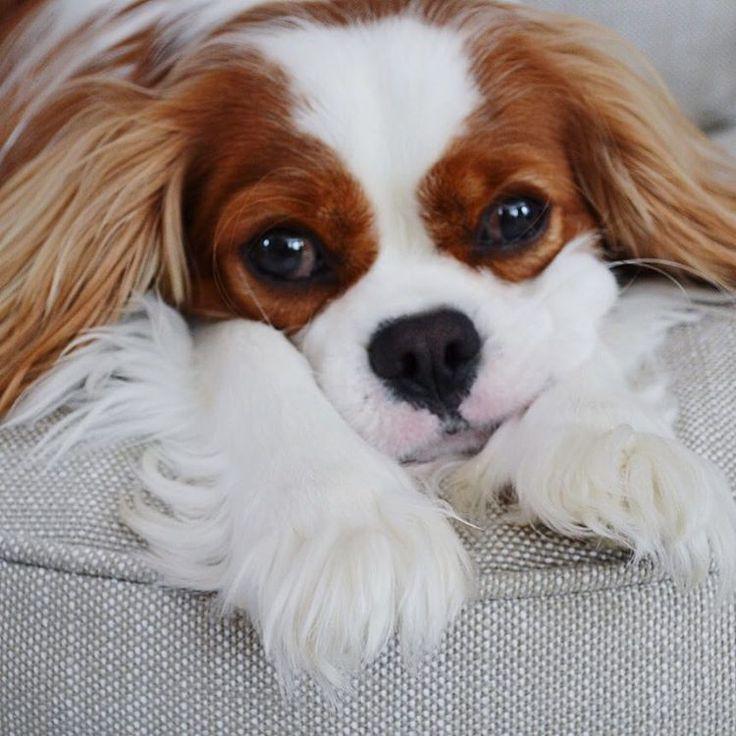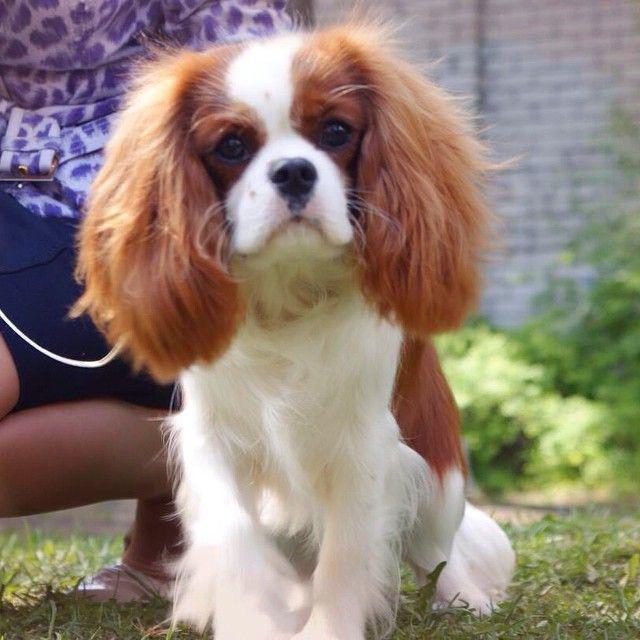The first image is the image on the left, the second image is the image on the right. For the images displayed, is the sentence "All the dogs are looking straight ahead." factually correct? Answer yes or no. Yes. The first image is the image on the left, the second image is the image on the right. Analyze the images presented: Is the assertion "One of the brown and white dogs has a toy." valid? Answer yes or no. No. 